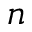<formula> <loc_0><loc_0><loc_500><loc_500>n</formula> 